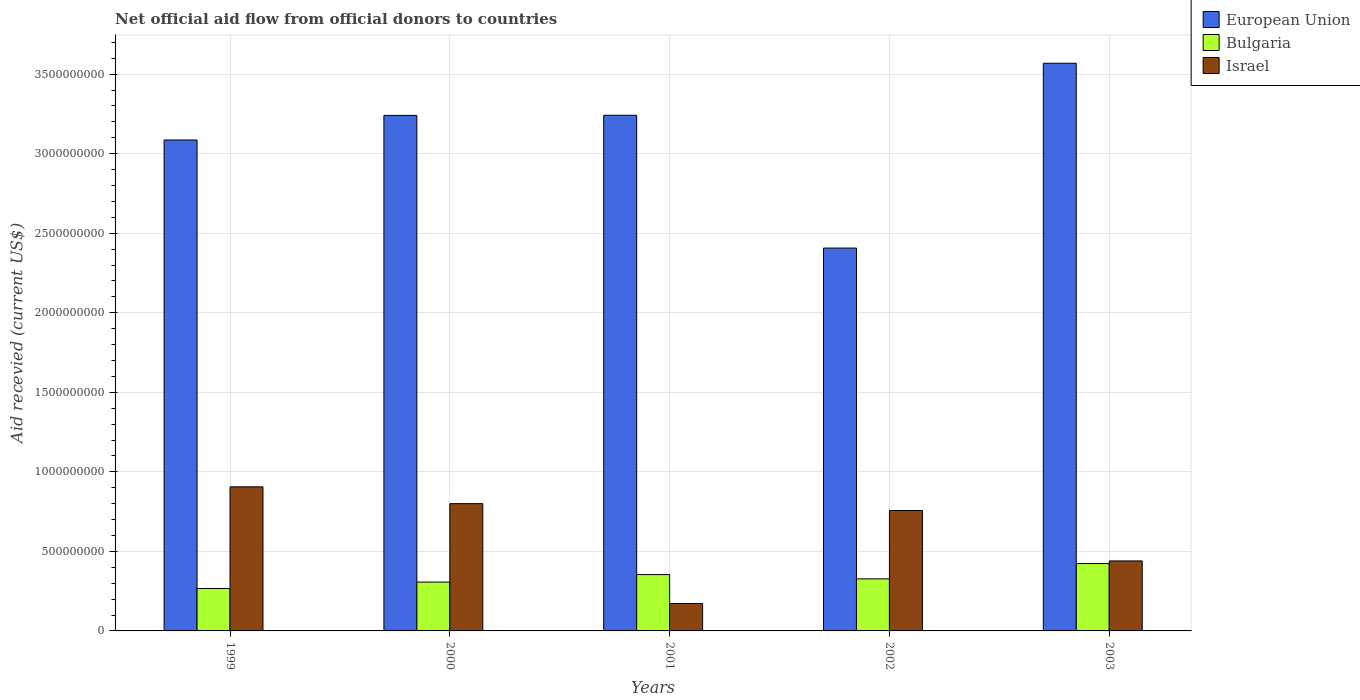How many groups of bars are there?
Provide a short and direct response. 5. Are the number of bars per tick equal to the number of legend labels?
Ensure brevity in your answer.  Yes. How many bars are there on the 1st tick from the right?
Provide a short and direct response. 3. In how many cases, is the number of bars for a given year not equal to the number of legend labels?
Give a very brief answer. 0. What is the total aid received in European Union in 2000?
Give a very brief answer. 3.24e+09. Across all years, what is the maximum total aid received in Bulgaria?
Your answer should be compact. 4.23e+08. Across all years, what is the minimum total aid received in Bulgaria?
Ensure brevity in your answer.  2.67e+08. In which year was the total aid received in Israel maximum?
Offer a very short reply. 1999. In which year was the total aid received in Israel minimum?
Your answer should be very brief. 2001. What is the total total aid received in European Union in the graph?
Make the answer very short. 1.55e+1. What is the difference between the total aid received in European Union in 2000 and that in 2003?
Offer a terse response. -3.28e+08. What is the difference between the total aid received in European Union in 2002 and the total aid received in Bulgaria in 1999?
Provide a succinct answer. 2.14e+09. What is the average total aid received in Israel per year?
Provide a succinct answer. 6.15e+08. In the year 2002, what is the difference between the total aid received in Bulgaria and total aid received in Israel?
Provide a short and direct response. -4.30e+08. What is the ratio of the total aid received in Israel in 2000 to that in 2001?
Your answer should be compact. 4.64. Is the total aid received in Israel in 2000 less than that in 2002?
Provide a short and direct response. No. What is the difference between the highest and the second highest total aid received in Bulgaria?
Keep it short and to the point. 6.94e+07. What is the difference between the highest and the lowest total aid received in Bulgaria?
Ensure brevity in your answer.  1.57e+08. In how many years, is the total aid received in Bulgaria greater than the average total aid received in Bulgaria taken over all years?
Offer a very short reply. 2. Is the sum of the total aid received in Israel in 2000 and 2002 greater than the maximum total aid received in European Union across all years?
Provide a succinct answer. No. What does the 3rd bar from the left in 2000 represents?
Provide a succinct answer. Israel. What does the 1st bar from the right in 2001 represents?
Offer a very short reply. Israel. Is it the case that in every year, the sum of the total aid received in Bulgaria and total aid received in European Union is greater than the total aid received in Israel?
Ensure brevity in your answer.  Yes. How many bars are there?
Provide a succinct answer. 15. Are all the bars in the graph horizontal?
Offer a terse response. No. How many years are there in the graph?
Offer a very short reply. 5. Are the values on the major ticks of Y-axis written in scientific E-notation?
Your response must be concise. No. Does the graph contain any zero values?
Ensure brevity in your answer.  No. Does the graph contain grids?
Provide a succinct answer. Yes. Where does the legend appear in the graph?
Your answer should be very brief. Top right. How are the legend labels stacked?
Give a very brief answer. Vertical. What is the title of the graph?
Make the answer very short. Net official aid flow from official donors to countries. Does "Cambodia" appear as one of the legend labels in the graph?
Ensure brevity in your answer.  No. What is the label or title of the X-axis?
Give a very brief answer. Years. What is the label or title of the Y-axis?
Your answer should be compact. Aid recevied (current US$). What is the Aid recevied (current US$) in European Union in 1999?
Keep it short and to the point. 3.09e+09. What is the Aid recevied (current US$) in Bulgaria in 1999?
Provide a short and direct response. 2.67e+08. What is the Aid recevied (current US$) of Israel in 1999?
Your answer should be very brief. 9.06e+08. What is the Aid recevied (current US$) of European Union in 2000?
Give a very brief answer. 3.24e+09. What is the Aid recevied (current US$) in Bulgaria in 2000?
Offer a very short reply. 3.07e+08. What is the Aid recevied (current US$) of Israel in 2000?
Provide a short and direct response. 8.00e+08. What is the Aid recevied (current US$) of European Union in 2001?
Keep it short and to the point. 3.24e+09. What is the Aid recevied (current US$) of Bulgaria in 2001?
Offer a terse response. 3.54e+08. What is the Aid recevied (current US$) of Israel in 2001?
Your answer should be compact. 1.72e+08. What is the Aid recevied (current US$) of European Union in 2002?
Your answer should be compact. 2.41e+09. What is the Aid recevied (current US$) in Bulgaria in 2002?
Provide a short and direct response. 3.27e+08. What is the Aid recevied (current US$) in Israel in 2002?
Make the answer very short. 7.57e+08. What is the Aid recevied (current US$) of European Union in 2003?
Your answer should be very brief. 3.57e+09. What is the Aid recevied (current US$) of Bulgaria in 2003?
Provide a succinct answer. 4.23e+08. What is the Aid recevied (current US$) of Israel in 2003?
Your response must be concise. 4.40e+08. Across all years, what is the maximum Aid recevied (current US$) of European Union?
Provide a short and direct response. 3.57e+09. Across all years, what is the maximum Aid recevied (current US$) in Bulgaria?
Your answer should be compact. 4.23e+08. Across all years, what is the maximum Aid recevied (current US$) of Israel?
Make the answer very short. 9.06e+08. Across all years, what is the minimum Aid recevied (current US$) of European Union?
Provide a short and direct response. 2.41e+09. Across all years, what is the minimum Aid recevied (current US$) in Bulgaria?
Offer a terse response. 2.67e+08. Across all years, what is the minimum Aid recevied (current US$) in Israel?
Provide a short and direct response. 1.72e+08. What is the total Aid recevied (current US$) in European Union in the graph?
Your answer should be compact. 1.55e+1. What is the total Aid recevied (current US$) of Bulgaria in the graph?
Your response must be concise. 1.68e+09. What is the total Aid recevied (current US$) in Israel in the graph?
Your answer should be compact. 3.07e+09. What is the difference between the Aid recevied (current US$) in European Union in 1999 and that in 2000?
Your response must be concise. -1.55e+08. What is the difference between the Aid recevied (current US$) of Bulgaria in 1999 and that in 2000?
Provide a succinct answer. -4.06e+07. What is the difference between the Aid recevied (current US$) in Israel in 1999 and that in 2000?
Your answer should be compact. 1.06e+08. What is the difference between the Aid recevied (current US$) of European Union in 1999 and that in 2001?
Offer a very short reply. -1.55e+08. What is the difference between the Aid recevied (current US$) in Bulgaria in 1999 and that in 2001?
Offer a very short reply. -8.75e+07. What is the difference between the Aid recevied (current US$) of Israel in 1999 and that in 2001?
Make the answer very short. 7.33e+08. What is the difference between the Aid recevied (current US$) in European Union in 1999 and that in 2002?
Make the answer very short. 6.79e+08. What is the difference between the Aid recevied (current US$) in Bulgaria in 1999 and that in 2002?
Offer a terse response. -6.07e+07. What is the difference between the Aid recevied (current US$) in Israel in 1999 and that in 2002?
Your answer should be very brief. 1.49e+08. What is the difference between the Aid recevied (current US$) of European Union in 1999 and that in 2003?
Provide a short and direct response. -4.82e+08. What is the difference between the Aid recevied (current US$) in Bulgaria in 1999 and that in 2003?
Offer a very short reply. -1.57e+08. What is the difference between the Aid recevied (current US$) of Israel in 1999 and that in 2003?
Provide a succinct answer. 4.66e+08. What is the difference between the Aid recevied (current US$) of European Union in 2000 and that in 2001?
Ensure brevity in your answer.  -7.70e+05. What is the difference between the Aid recevied (current US$) of Bulgaria in 2000 and that in 2001?
Provide a succinct answer. -4.69e+07. What is the difference between the Aid recevied (current US$) in Israel in 2000 and that in 2001?
Keep it short and to the point. 6.28e+08. What is the difference between the Aid recevied (current US$) in European Union in 2000 and that in 2002?
Ensure brevity in your answer.  8.34e+08. What is the difference between the Aid recevied (current US$) in Bulgaria in 2000 and that in 2002?
Make the answer very short. -2.01e+07. What is the difference between the Aid recevied (current US$) in Israel in 2000 and that in 2002?
Ensure brevity in your answer.  4.31e+07. What is the difference between the Aid recevied (current US$) in European Union in 2000 and that in 2003?
Give a very brief answer. -3.28e+08. What is the difference between the Aid recevied (current US$) of Bulgaria in 2000 and that in 2003?
Your answer should be very brief. -1.16e+08. What is the difference between the Aid recevied (current US$) of Israel in 2000 and that in 2003?
Ensure brevity in your answer.  3.60e+08. What is the difference between the Aid recevied (current US$) in European Union in 2001 and that in 2002?
Your answer should be very brief. 8.35e+08. What is the difference between the Aid recevied (current US$) of Bulgaria in 2001 and that in 2002?
Your answer should be compact. 2.68e+07. What is the difference between the Aid recevied (current US$) of Israel in 2001 and that in 2002?
Keep it short and to the point. -5.85e+08. What is the difference between the Aid recevied (current US$) in European Union in 2001 and that in 2003?
Ensure brevity in your answer.  -3.27e+08. What is the difference between the Aid recevied (current US$) in Bulgaria in 2001 and that in 2003?
Make the answer very short. -6.94e+07. What is the difference between the Aid recevied (current US$) of Israel in 2001 and that in 2003?
Your response must be concise. -2.68e+08. What is the difference between the Aid recevied (current US$) in European Union in 2002 and that in 2003?
Provide a short and direct response. -1.16e+09. What is the difference between the Aid recevied (current US$) of Bulgaria in 2002 and that in 2003?
Make the answer very short. -9.62e+07. What is the difference between the Aid recevied (current US$) in Israel in 2002 and that in 2003?
Ensure brevity in your answer.  3.17e+08. What is the difference between the Aid recevied (current US$) in European Union in 1999 and the Aid recevied (current US$) in Bulgaria in 2000?
Keep it short and to the point. 2.78e+09. What is the difference between the Aid recevied (current US$) of European Union in 1999 and the Aid recevied (current US$) of Israel in 2000?
Keep it short and to the point. 2.29e+09. What is the difference between the Aid recevied (current US$) of Bulgaria in 1999 and the Aid recevied (current US$) of Israel in 2000?
Provide a short and direct response. -5.33e+08. What is the difference between the Aid recevied (current US$) in European Union in 1999 and the Aid recevied (current US$) in Bulgaria in 2001?
Keep it short and to the point. 2.73e+09. What is the difference between the Aid recevied (current US$) of European Union in 1999 and the Aid recevied (current US$) of Israel in 2001?
Provide a short and direct response. 2.91e+09. What is the difference between the Aid recevied (current US$) of Bulgaria in 1999 and the Aid recevied (current US$) of Israel in 2001?
Offer a very short reply. 9.42e+07. What is the difference between the Aid recevied (current US$) in European Union in 1999 and the Aid recevied (current US$) in Bulgaria in 2002?
Your response must be concise. 2.76e+09. What is the difference between the Aid recevied (current US$) of European Union in 1999 and the Aid recevied (current US$) of Israel in 2002?
Keep it short and to the point. 2.33e+09. What is the difference between the Aid recevied (current US$) in Bulgaria in 1999 and the Aid recevied (current US$) in Israel in 2002?
Ensure brevity in your answer.  -4.90e+08. What is the difference between the Aid recevied (current US$) of European Union in 1999 and the Aid recevied (current US$) of Bulgaria in 2003?
Keep it short and to the point. 2.66e+09. What is the difference between the Aid recevied (current US$) of European Union in 1999 and the Aid recevied (current US$) of Israel in 2003?
Your response must be concise. 2.65e+09. What is the difference between the Aid recevied (current US$) of Bulgaria in 1999 and the Aid recevied (current US$) of Israel in 2003?
Your response must be concise. -1.73e+08. What is the difference between the Aid recevied (current US$) in European Union in 2000 and the Aid recevied (current US$) in Bulgaria in 2001?
Ensure brevity in your answer.  2.89e+09. What is the difference between the Aid recevied (current US$) of European Union in 2000 and the Aid recevied (current US$) of Israel in 2001?
Your response must be concise. 3.07e+09. What is the difference between the Aid recevied (current US$) in Bulgaria in 2000 and the Aid recevied (current US$) in Israel in 2001?
Your answer should be very brief. 1.35e+08. What is the difference between the Aid recevied (current US$) of European Union in 2000 and the Aid recevied (current US$) of Bulgaria in 2002?
Your response must be concise. 2.91e+09. What is the difference between the Aid recevied (current US$) in European Union in 2000 and the Aid recevied (current US$) in Israel in 2002?
Your answer should be compact. 2.48e+09. What is the difference between the Aid recevied (current US$) in Bulgaria in 2000 and the Aid recevied (current US$) in Israel in 2002?
Provide a short and direct response. -4.50e+08. What is the difference between the Aid recevied (current US$) in European Union in 2000 and the Aid recevied (current US$) in Bulgaria in 2003?
Offer a very short reply. 2.82e+09. What is the difference between the Aid recevied (current US$) of European Union in 2000 and the Aid recevied (current US$) of Israel in 2003?
Keep it short and to the point. 2.80e+09. What is the difference between the Aid recevied (current US$) of Bulgaria in 2000 and the Aid recevied (current US$) of Israel in 2003?
Keep it short and to the point. -1.33e+08. What is the difference between the Aid recevied (current US$) in European Union in 2001 and the Aid recevied (current US$) in Bulgaria in 2002?
Your answer should be very brief. 2.91e+09. What is the difference between the Aid recevied (current US$) of European Union in 2001 and the Aid recevied (current US$) of Israel in 2002?
Your answer should be very brief. 2.48e+09. What is the difference between the Aid recevied (current US$) of Bulgaria in 2001 and the Aid recevied (current US$) of Israel in 2002?
Provide a succinct answer. -4.03e+08. What is the difference between the Aid recevied (current US$) of European Union in 2001 and the Aid recevied (current US$) of Bulgaria in 2003?
Give a very brief answer. 2.82e+09. What is the difference between the Aid recevied (current US$) in European Union in 2001 and the Aid recevied (current US$) in Israel in 2003?
Ensure brevity in your answer.  2.80e+09. What is the difference between the Aid recevied (current US$) of Bulgaria in 2001 and the Aid recevied (current US$) of Israel in 2003?
Your response must be concise. -8.59e+07. What is the difference between the Aid recevied (current US$) of European Union in 2002 and the Aid recevied (current US$) of Bulgaria in 2003?
Provide a succinct answer. 1.98e+09. What is the difference between the Aid recevied (current US$) of European Union in 2002 and the Aid recevied (current US$) of Israel in 2003?
Keep it short and to the point. 1.97e+09. What is the difference between the Aid recevied (current US$) of Bulgaria in 2002 and the Aid recevied (current US$) of Israel in 2003?
Ensure brevity in your answer.  -1.13e+08. What is the average Aid recevied (current US$) of European Union per year?
Make the answer very short. 3.11e+09. What is the average Aid recevied (current US$) of Bulgaria per year?
Keep it short and to the point. 3.36e+08. What is the average Aid recevied (current US$) in Israel per year?
Offer a terse response. 6.15e+08. In the year 1999, what is the difference between the Aid recevied (current US$) of European Union and Aid recevied (current US$) of Bulgaria?
Offer a terse response. 2.82e+09. In the year 1999, what is the difference between the Aid recevied (current US$) of European Union and Aid recevied (current US$) of Israel?
Provide a succinct answer. 2.18e+09. In the year 1999, what is the difference between the Aid recevied (current US$) in Bulgaria and Aid recevied (current US$) in Israel?
Provide a short and direct response. -6.39e+08. In the year 2000, what is the difference between the Aid recevied (current US$) in European Union and Aid recevied (current US$) in Bulgaria?
Provide a short and direct response. 2.93e+09. In the year 2000, what is the difference between the Aid recevied (current US$) of European Union and Aid recevied (current US$) of Israel?
Ensure brevity in your answer.  2.44e+09. In the year 2000, what is the difference between the Aid recevied (current US$) of Bulgaria and Aid recevied (current US$) of Israel?
Provide a short and direct response. -4.93e+08. In the year 2001, what is the difference between the Aid recevied (current US$) in European Union and Aid recevied (current US$) in Bulgaria?
Offer a very short reply. 2.89e+09. In the year 2001, what is the difference between the Aid recevied (current US$) of European Union and Aid recevied (current US$) of Israel?
Ensure brevity in your answer.  3.07e+09. In the year 2001, what is the difference between the Aid recevied (current US$) in Bulgaria and Aid recevied (current US$) in Israel?
Keep it short and to the point. 1.82e+08. In the year 2002, what is the difference between the Aid recevied (current US$) in European Union and Aid recevied (current US$) in Bulgaria?
Offer a very short reply. 2.08e+09. In the year 2002, what is the difference between the Aid recevied (current US$) of European Union and Aid recevied (current US$) of Israel?
Give a very brief answer. 1.65e+09. In the year 2002, what is the difference between the Aid recevied (current US$) of Bulgaria and Aid recevied (current US$) of Israel?
Ensure brevity in your answer.  -4.30e+08. In the year 2003, what is the difference between the Aid recevied (current US$) of European Union and Aid recevied (current US$) of Bulgaria?
Offer a very short reply. 3.14e+09. In the year 2003, what is the difference between the Aid recevied (current US$) in European Union and Aid recevied (current US$) in Israel?
Your answer should be compact. 3.13e+09. In the year 2003, what is the difference between the Aid recevied (current US$) of Bulgaria and Aid recevied (current US$) of Israel?
Ensure brevity in your answer.  -1.66e+07. What is the ratio of the Aid recevied (current US$) in European Union in 1999 to that in 2000?
Offer a very short reply. 0.95. What is the ratio of the Aid recevied (current US$) of Bulgaria in 1999 to that in 2000?
Give a very brief answer. 0.87. What is the ratio of the Aid recevied (current US$) in Israel in 1999 to that in 2000?
Provide a succinct answer. 1.13. What is the ratio of the Aid recevied (current US$) in European Union in 1999 to that in 2001?
Ensure brevity in your answer.  0.95. What is the ratio of the Aid recevied (current US$) in Bulgaria in 1999 to that in 2001?
Your response must be concise. 0.75. What is the ratio of the Aid recevied (current US$) of Israel in 1999 to that in 2001?
Offer a terse response. 5.26. What is the ratio of the Aid recevied (current US$) of European Union in 1999 to that in 2002?
Your answer should be very brief. 1.28. What is the ratio of the Aid recevied (current US$) of Bulgaria in 1999 to that in 2002?
Provide a short and direct response. 0.81. What is the ratio of the Aid recevied (current US$) of Israel in 1999 to that in 2002?
Your answer should be very brief. 1.2. What is the ratio of the Aid recevied (current US$) in European Union in 1999 to that in 2003?
Ensure brevity in your answer.  0.86. What is the ratio of the Aid recevied (current US$) in Bulgaria in 1999 to that in 2003?
Make the answer very short. 0.63. What is the ratio of the Aid recevied (current US$) in Israel in 1999 to that in 2003?
Your response must be concise. 2.06. What is the ratio of the Aid recevied (current US$) of European Union in 2000 to that in 2001?
Keep it short and to the point. 1. What is the ratio of the Aid recevied (current US$) in Bulgaria in 2000 to that in 2001?
Give a very brief answer. 0.87. What is the ratio of the Aid recevied (current US$) in Israel in 2000 to that in 2001?
Give a very brief answer. 4.64. What is the ratio of the Aid recevied (current US$) of European Union in 2000 to that in 2002?
Make the answer very short. 1.35. What is the ratio of the Aid recevied (current US$) in Bulgaria in 2000 to that in 2002?
Provide a succinct answer. 0.94. What is the ratio of the Aid recevied (current US$) in Israel in 2000 to that in 2002?
Provide a short and direct response. 1.06. What is the ratio of the Aid recevied (current US$) in European Union in 2000 to that in 2003?
Keep it short and to the point. 0.91. What is the ratio of the Aid recevied (current US$) of Bulgaria in 2000 to that in 2003?
Keep it short and to the point. 0.73. What is the ratio of the Aid recevied (current US$) of Israel in 2000 to that in 2003?
Ensure brevity in your answer.  1.82. What is the ratio of the Aid recevied (current US$) in European Union in 2001 to that in 2002?
Provide a succinct answer. 1.35. What is the ratio of the Aid recevied (current US$) in Bulgaria in 2001 to that in 2002?
Provide a succinct answer. 1.08. What is the ratio of the Aid recevied (current US$) in Israel in 2001 to that in 2002?
Offer a terse response. 0.23. What is the ratio of the Aid recevied (current US$) in European Union in 2001 to that in 2003?
Keep it short and to the point. 0.91. What is the ratio of the Aid recevied (current US$) in Bulgaria in 2001 to that in 2003?
Your answer should be very brief. 0.84. What is the ratio of the Aid recevied (current US$) in Israel in 2001 to that in 2003?
Make the answer very short. 0.39. What is the ratio of the Aid recevied (current US$) of European Union in 2002 to that in 2003?
Your answer should be very brief. 0.67. What is the ratio of the Aid recevied (current US$) in Bulgaria in 2002 to that in 2003?
Provide a succinct answer. 0.77. What is the ratio of the Aid recevied (current US$) of Israel in 2002 to that in 2003?
Keep it short and to the point. 1.72. What is the difference between the highest and the second highest Aid recevied (current US$) in European Union?
Give a very brief answer. 3.27e+08. What is the difference between the highest and the second highest Aid recevied (current US$) of Bulgaria?
Offer a very short reply. 6.94e+07. What is the difference between the highest and the second highest Aid recevied (current US$) in Israel?
Your answer should be very brief. 1.06e+08. What is the difference between the highest and the lowest Aid recevied (current US$) of European Union?
Your response must be concise. 1.16e+09. What is the difference between the highest and the lowest Aid recevied (current US$) in Bulgaria?
Offer a very short reply. 1.57e+08. What is the difference between the highest and the lowest Aid recevied (current US$) in Israel?
Your answer should be very brief. 7.33e+08. 